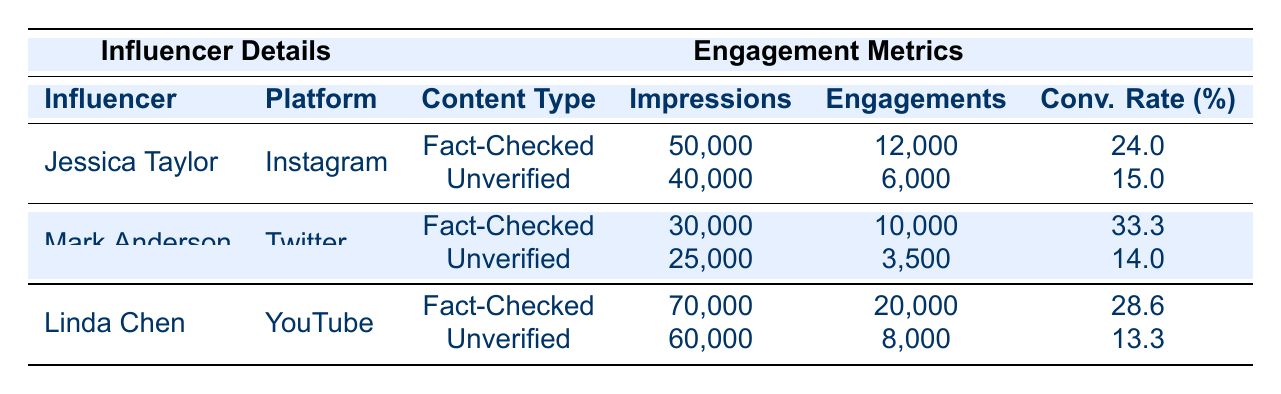What is the conversion rate for Jessica Taylor's fact-checked content on Instagram? From the table, Jessica Taylor's fact-checked content has a conversion rate listed as 24.0%.
Answer: 24.0 What were the total impressions for Mark Anderson's unverified content on Twitter? According to the table, the total impressions for Mark Anderson's unverified content is 25,000.
Answer: 25,000 Who had the highest conversion rate for fact-checked content? By comparing the conversion rates for fact-checked content, Mark Anderson has the highest conversion rate at 33.3%.
Answer: Mark Anderson What is the difference in conversion rates between fact-checked and unverified content for Linda Chen on YouTube? Linda Chen's fact-checked content has a conversion rate of 28.6%, while her unverified content has a conversion rate of 13.3%. The difference is calculated as 28.6% - 13.3% = 15.3%.
Answer: 15.3% Is the conversion rate for unverified content by Jessica Taylor higher than 10%? The conversion rate for Jessica Taylor's unverified content is 15.0%, which is indeed higher than 10%.
Answer: Yes What is the average conversion rate for fact-checked content among all influencers? The conversion rates for fact-checked content are 24.0% (Jessica Taylor), 33.3% (Mark Anderson), and 28.6% (Linda Chen). Adding these rates gives 85.9%, and dividing by the 3 influencers gives an average of 85.9% / 3 = 28.63%.
Answer: 28.63% How many engagements did Linda Chen receive for her unverified content? The table shows that Linda Chen received 8,000 engagements for her unverified content.
Answer: 8,000 Did any influencer have a lower conversion rate for unverified content than Jessica Taylor? Jessica Taylor has a conversion rate of 15.0% for her unverified content. Both Mark Anderson (14.0%) and Linda Chen (13.3%) have lower conversion rates. Thus, the answer is yes.
Answer: Yes What content type had a higher total engagement across all influencers? Total engagement for fact-checked content adds up to 12,000 (Jessica Taylor) + 10,000 (Mark Anderson) + 20,000 (Linda Chen) = 42,000. Total engagement for unverified content is 6,000 (Jessica Taylor) + 3,500 (Mark Anderson) + 8,000 (Linda Chen) = 17,500. Since 42,000 is greater than 17,500, the fact-checked content had higher total engagement.
Answer: Fact-Checked Content 